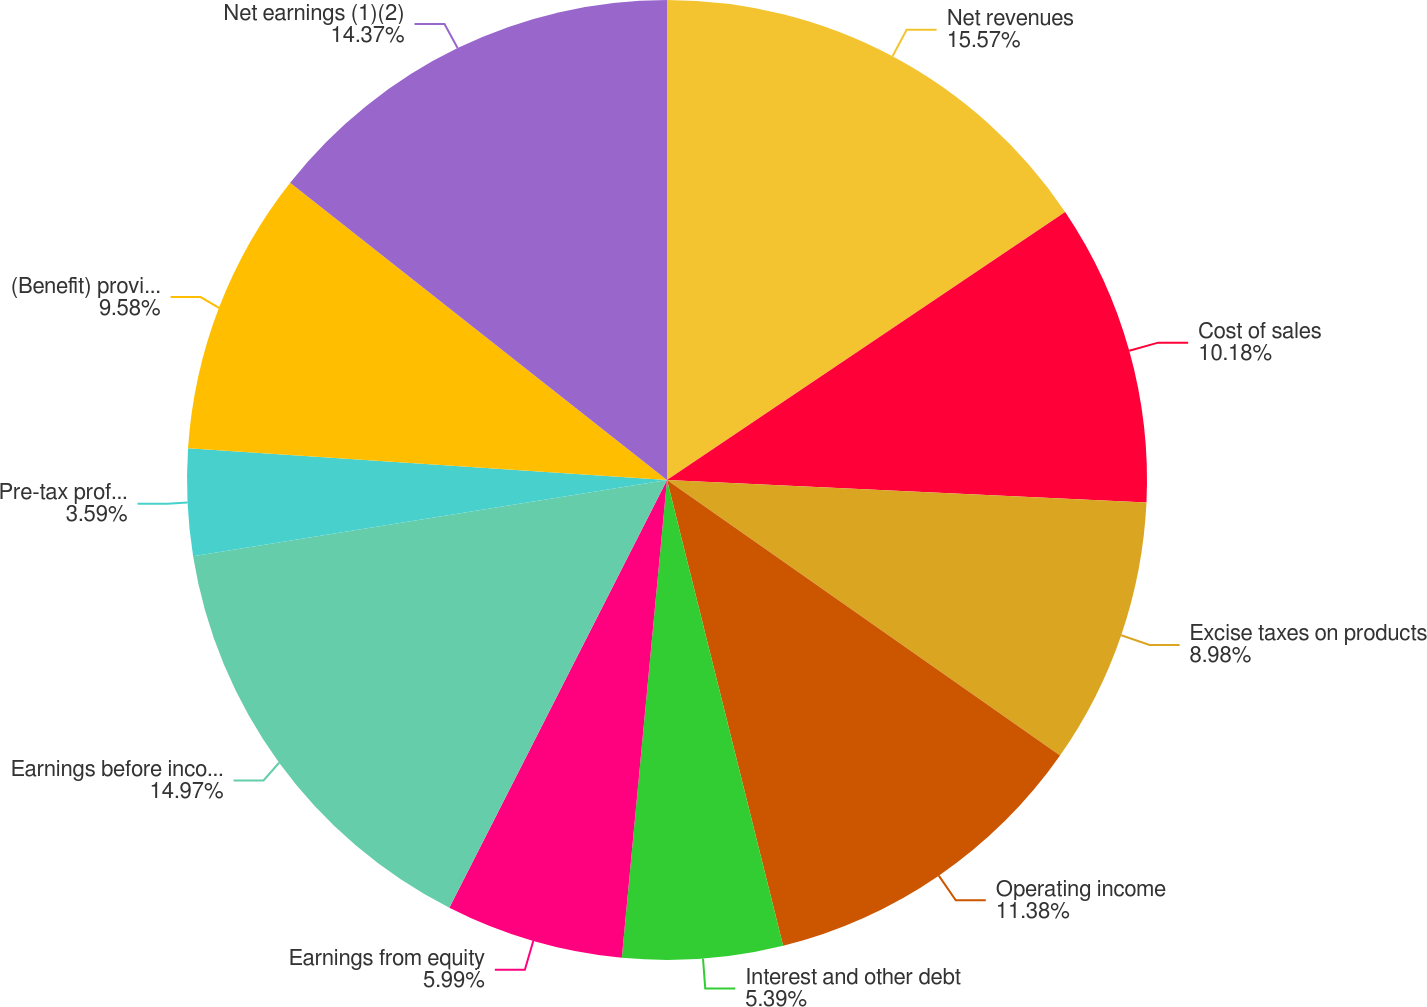Convert chart to OTSL. <chart><loc_0><loc_0><loc_500><loc_500><pie_chart><fcel>Net revenues<fcel>Cost of sales<fcel>Excise taxes on products<fcel>Operating income<fcel>Interest and other debt<fcel>Earnings from equity<fcel>Earnings before income taxes<fcel>Pre-tax profit margin (2)<fcel>(Benefit) provision for income<fcel>Net earnings (1)(2)<nl><fcel>15.57%<fcel>10.18%<fcel>8.98%<fcel>11.38%<fcel>5.39%<fcel>5.99%<fcel>14.97%<fcel>3.59%<fcel>9.58%<fcel>14.37%<nl></chart> 